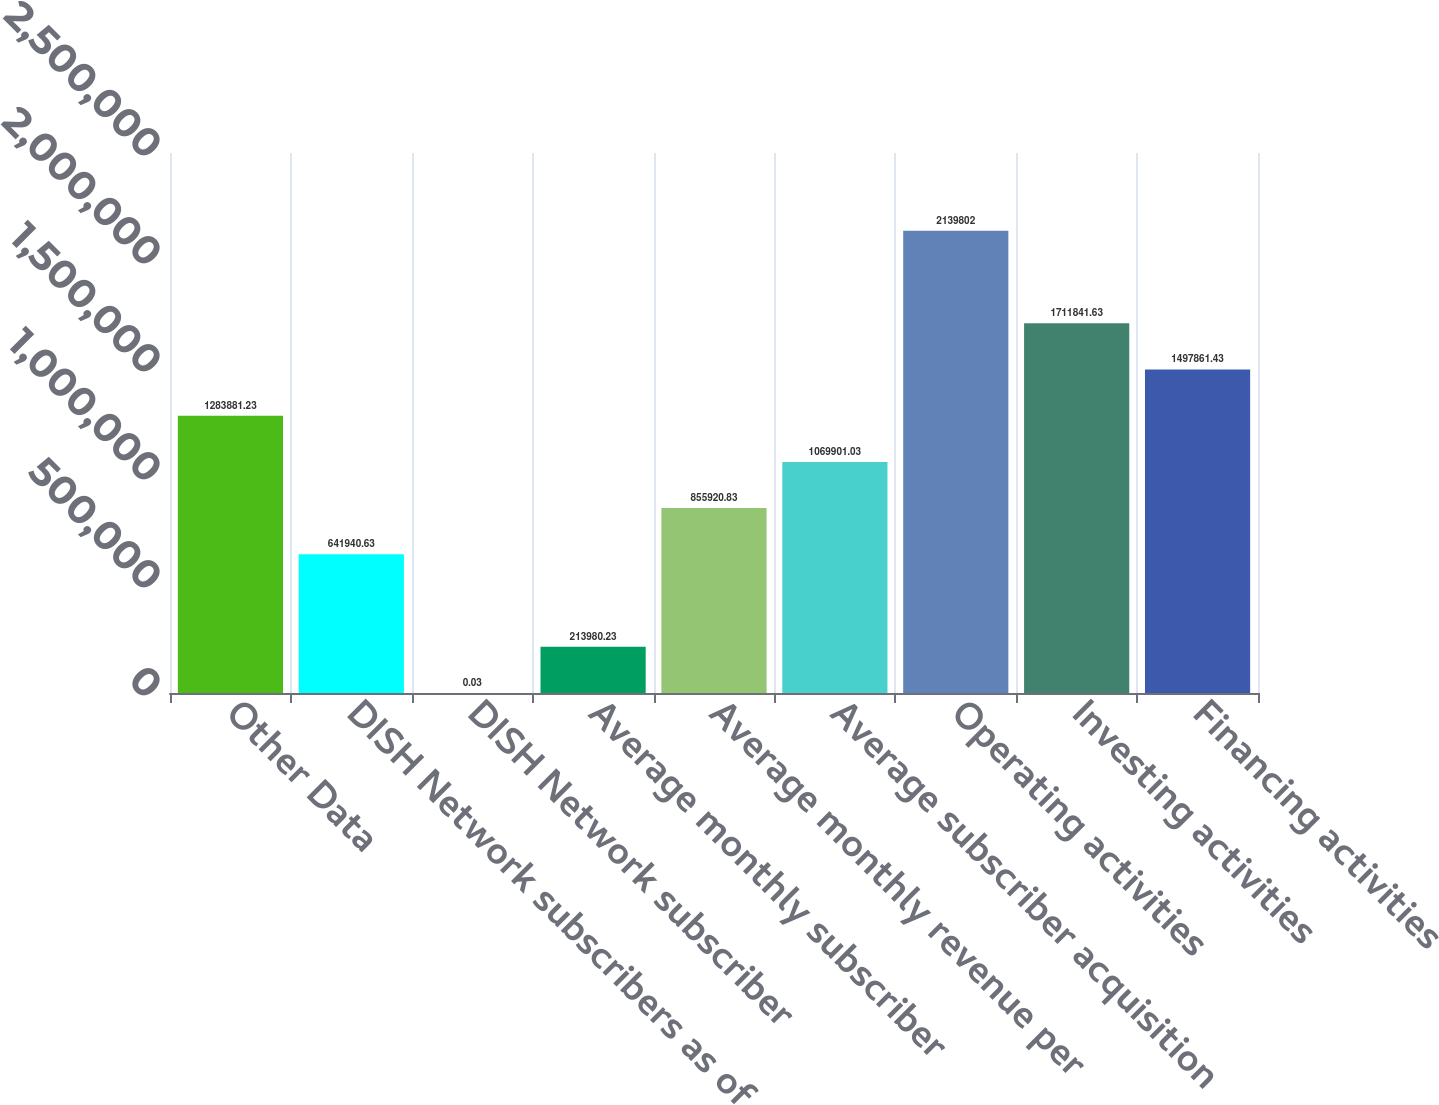Convert chart. <chart><loc_0><loc_0><loc_500><loc_500><bar_chart><fcel>Other Data<fcel>DISH Network subscribers as of<fcel>DISH Network subscriber<fcel>Average monthly subscriber<fcel>Average monthly revenue per<fcel>Average subscriber acquisition<fcel>Operating activities<fcel>Investing activities<fcel>Financing activities<nl><fcel>1.28388e+06<fcel>641941<fcel>0.03<fcel>213980<fcel>855921<fcel>1.0699e+06<fcel>2.1398e+06<fcel>1.71184e+06<fcel>1.49786e+06<nl></chart> 